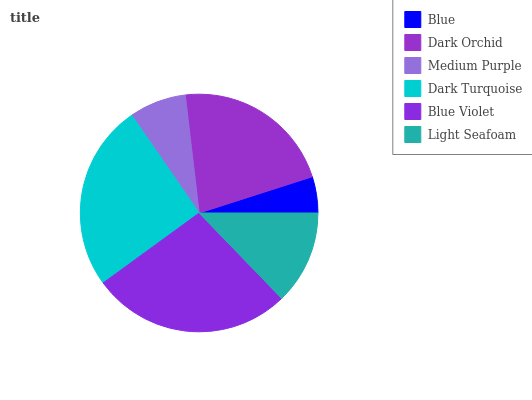Is Blue the minimum?
Answer yes or no. Yes. Is Blue Violet the maximum?
Answer yes or no. Yes. Is Dark Orchid the minimum?
Answer yes or no. No. Is Dark Orchid the maximum?
Answer yes or no. No. Is Dark Orchid greater than Blue?
Answer yes or no. Yes. Is Blue less than Dark Orchid?
Answer yes or no. Yes. Is Blue greater than Dark Orchid?
Answer yes or no. No. Is Dark Orchid less than Blue?
Answer yes or no. No. Is Dark Orchid the high median?
Answer yes or no. Yes. Is Light Seafoam the low median?
Answer yes or no. Yes. Is Medium Purple the high median?
Answer yes or no. No. Is Dark Turquoise the low median?
Answer yes or no. No. 